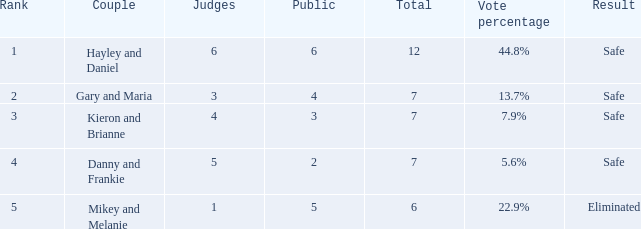What is the population present when the vote share was 2 1.0. 